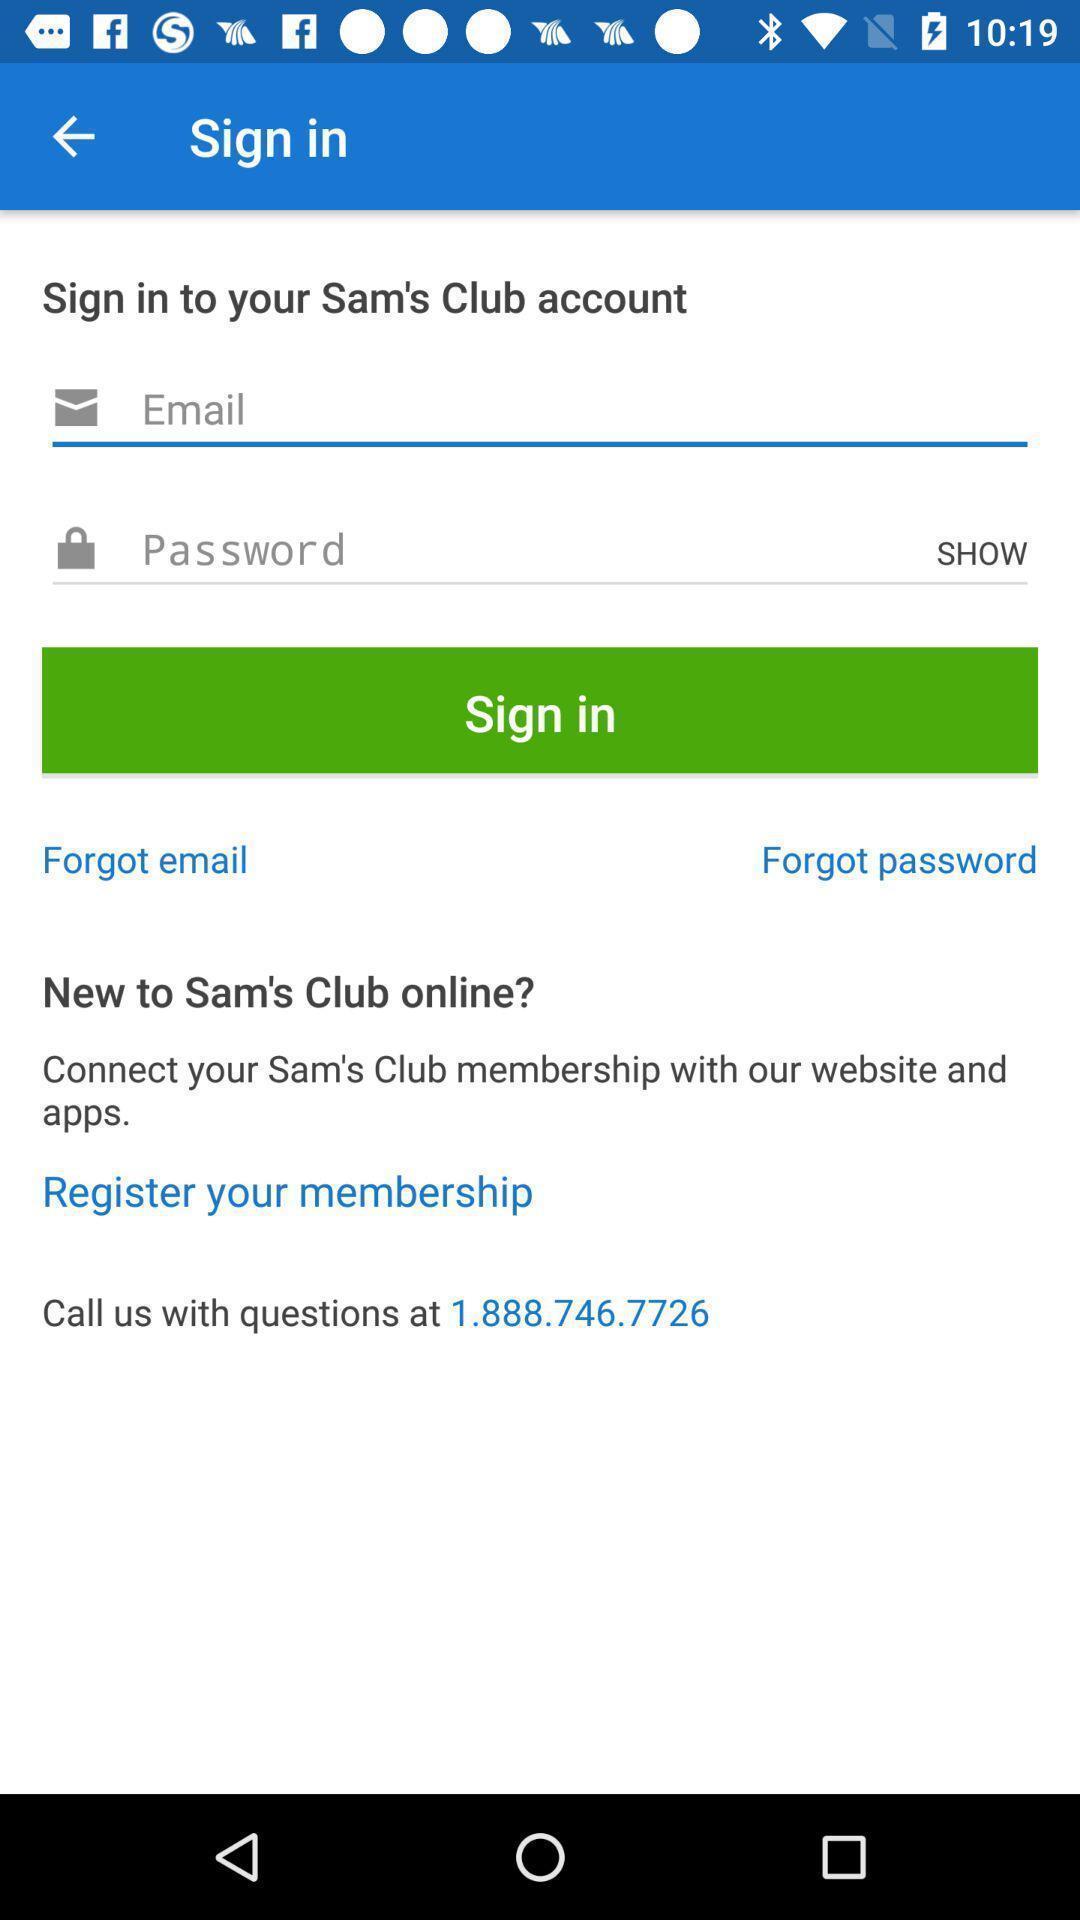Give me a narrative description of this picture. Sign-in page is displaying. 